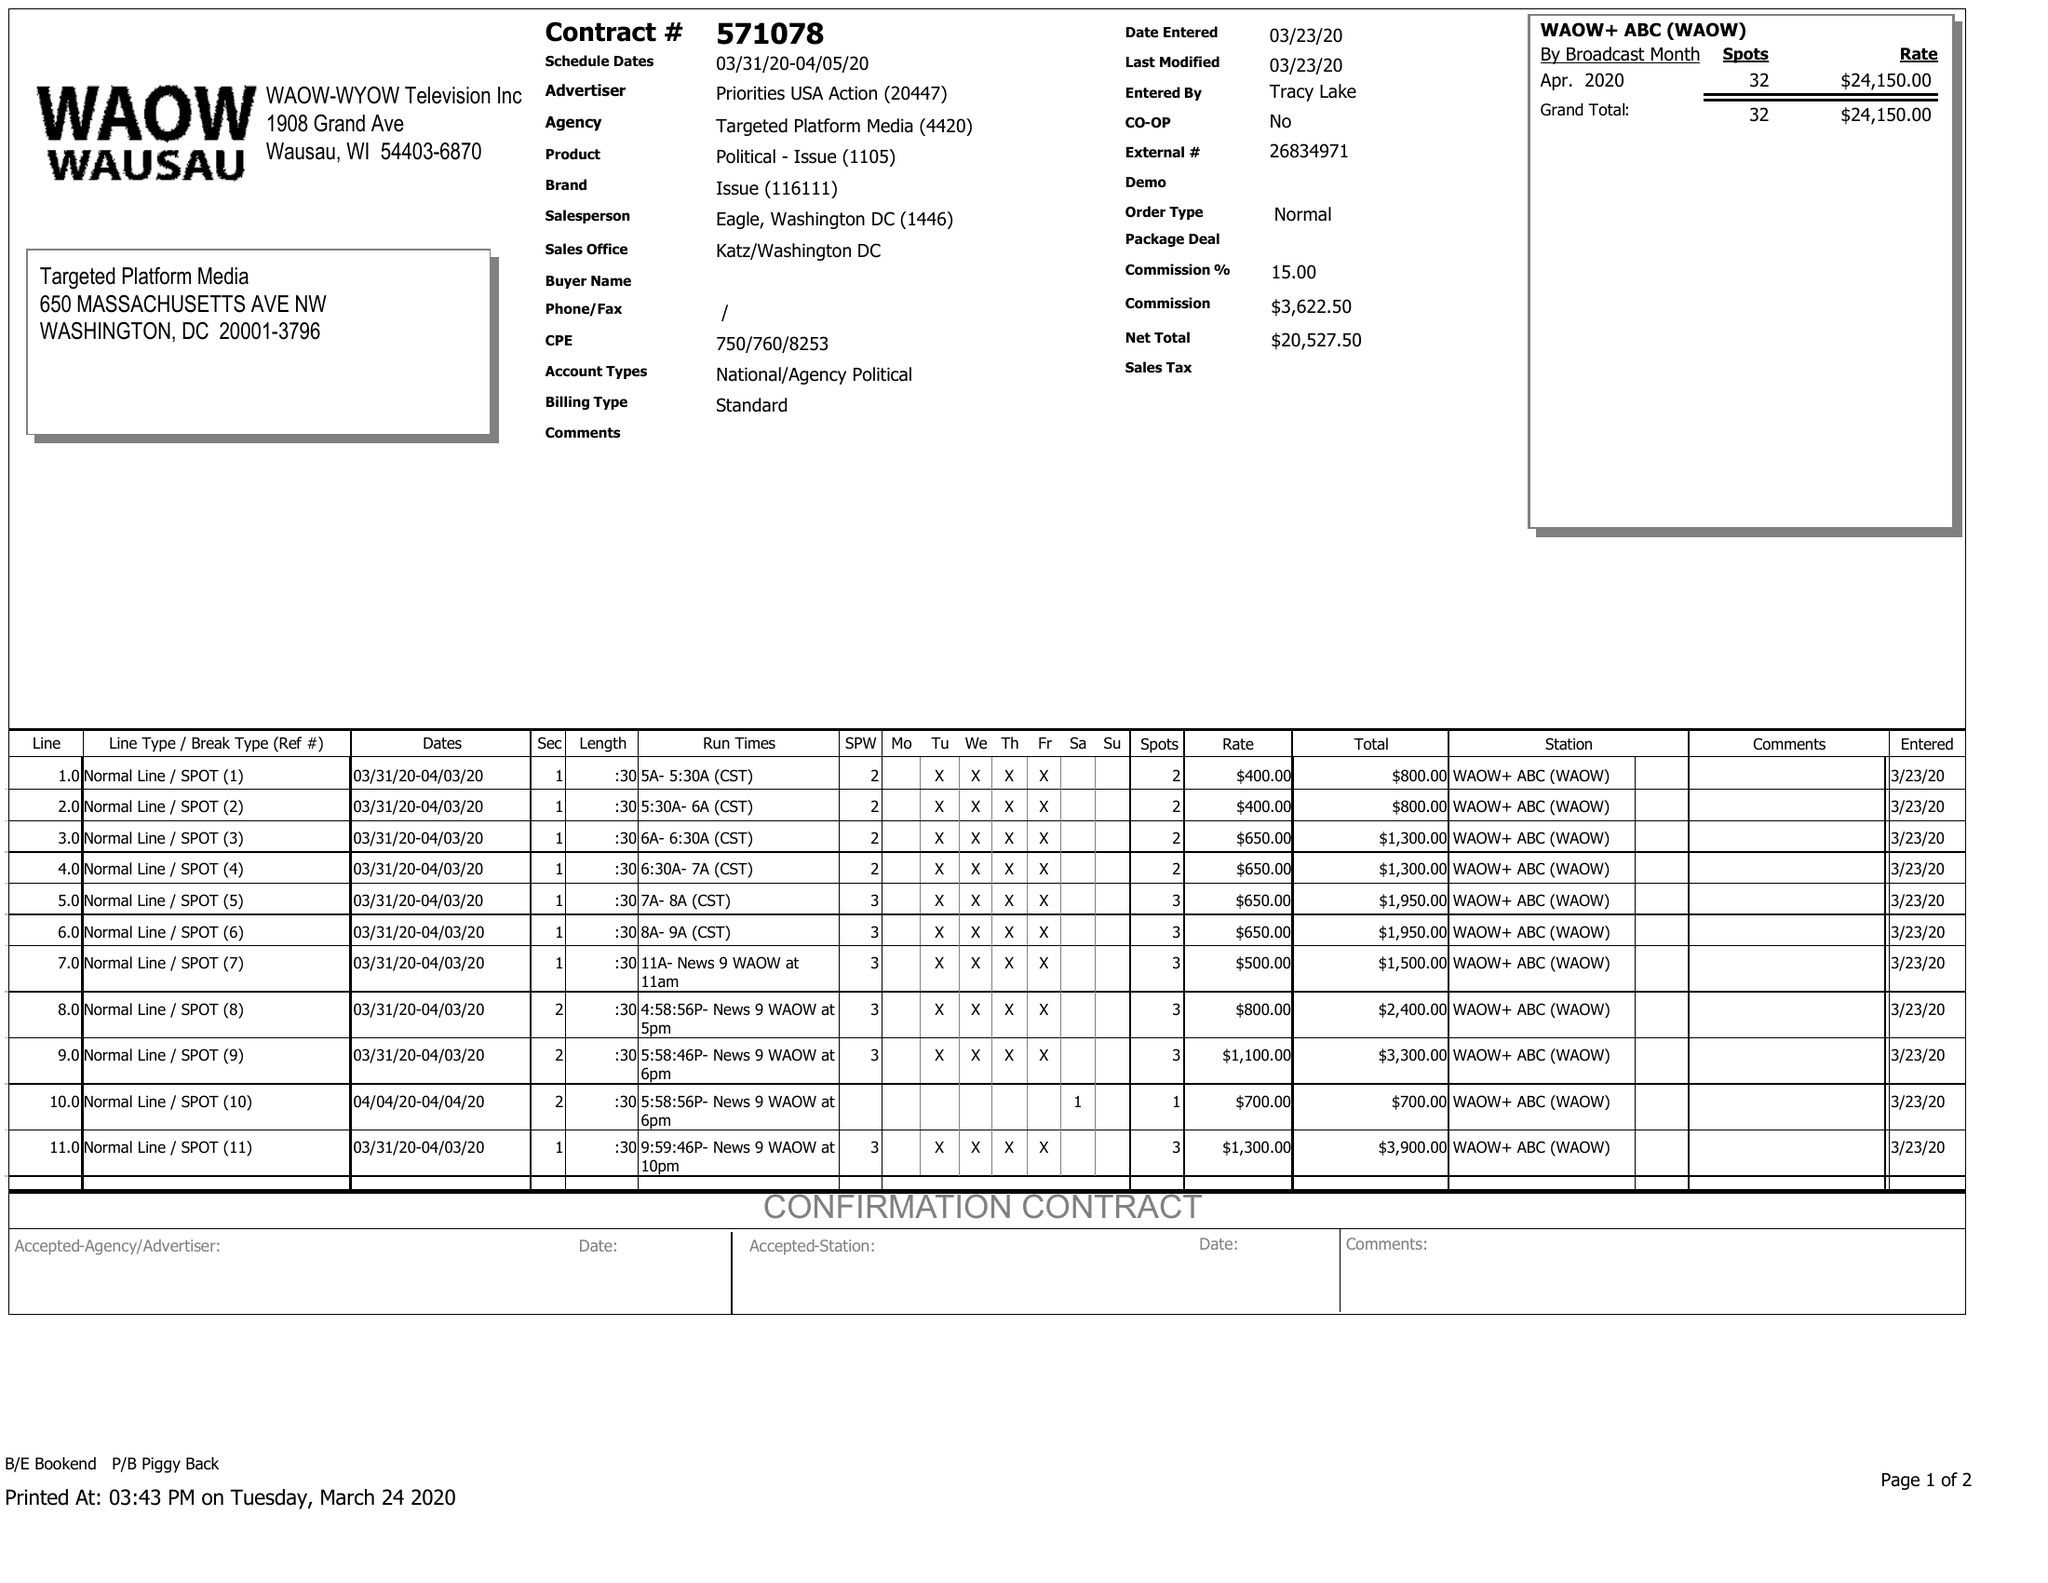What is the value for the gross_amount?
Answer the question using a single word or phrase. 24150.00 